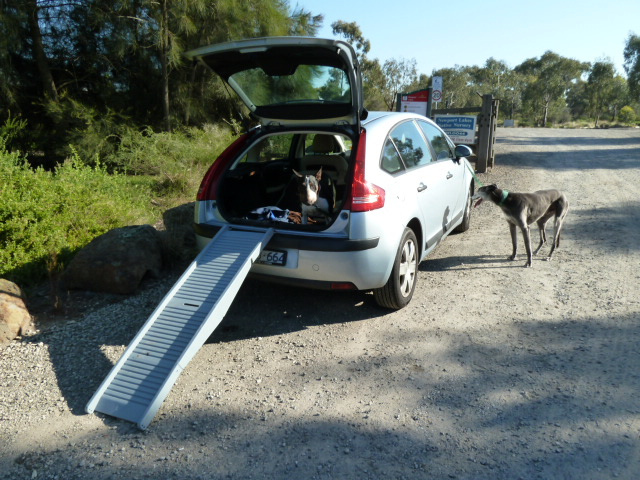If the car was transformed into a futuristic vehicle, what advanced features might it have to help the dogs? In a futuristic version of this car, it might feature an automated ramp system that adjusts its angle based on the dog's size and age, an in-car hydration and feeding station, a built-in pet bed with temperature control, and a virtual reality window where dogs can experience different landscapes and smells while traveling. Additionally, there might be a real-time health monitoring system that tracks the dogs' vitals and behavior to ensure they are comfortable and safe during the journey.  Integrate the above futuristic features in a novel where the dogs are part of a space expedition team. In the not-so-distant future, Max and Bella are not just ordinary dogs—they're part of the elite Space Canine Expedition Team. Their spaceship, equipped with all the latest technology, ensures they are comfortable for their long space journeys. The automated ramp adjusts seamlessly as they board the ship, leading them to their dedicated zero-gravity pet capsule beds, which keep them secured and comfortable regardless of the ship's orientation. The capsule beds have built-in hydration and nutrition systems that provide essential nutrients while monitoring their health in real-time. As the spaceship travels through space, the virtual reality windows give Max and Bella the feeling of running through endless fields and forests, keeping them happy and active. On their first mission to the newly discovered planet Zpriton, they are tasked with exploring the new terrain and investigating its ecological systems. The team encounters exotic alien creatures and plants, mapping the terrain and sending valuable data back to Earth. Max and Bella, with their advanced training and state-of-the-art gear, play a crucial role in the success of the mission, proving that even in the vastness of space, the bond between humans and their canine companions remains unbreakable. 